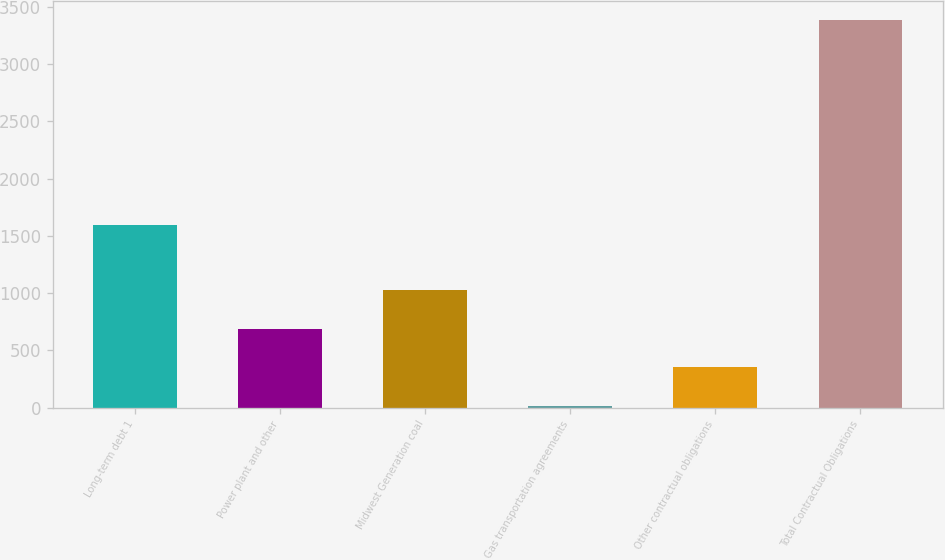Convert chart to OTSL. <chart><loc_0><loc_0><loc_500><loc_500><bar_chart><fcel>Long-term debt 1<fcel>Power plant and other<fcel>Midwest Generation coal<fcel>Gas transportation agreements<fcel>Other contractual obligations<fcel>Total Contractual Obligations<nl><fcel>1594<fcel>688<fcel>1025<fcel>14<fcel>351<fcel>3384<nl></chart> 